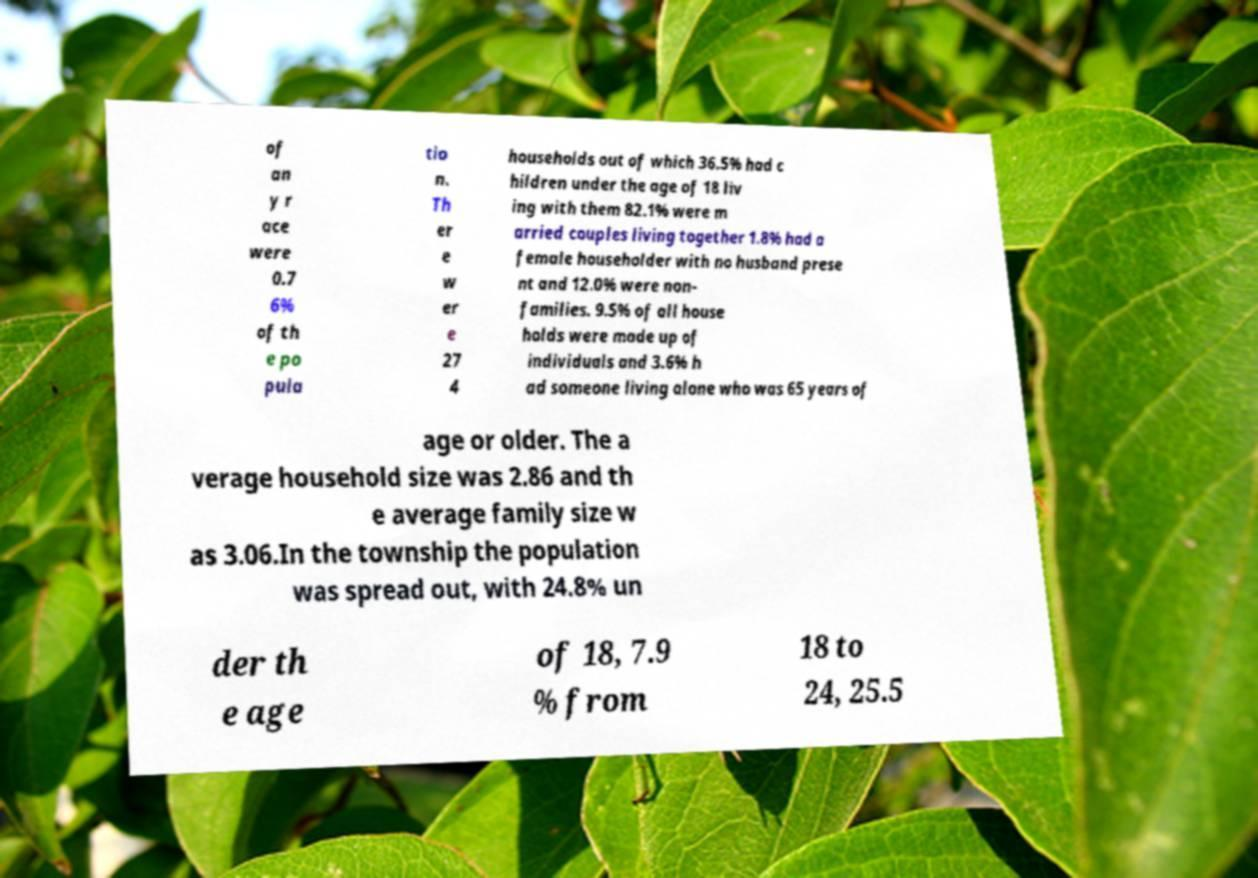Please read and relay the text visible in this image. What does it say? of an y r ace were 0.7 6% of th e po pula tio n. Th er e w er e 27 4 households out of which 36.5% had c hildren under the age of 18 liv ing with them 82.1% were m arried couples living together 1.8% had a female householder with no husband prese nt and 12.0% were non- families. 9.5% of all house holds were made up of individuals and 3.6% h ad someone living alone who was 65 years of age or older. The a verage household size was 2.86 and th e average family size w as 3.06.In the township the population was spread out, with 24.8% un der th e age of 18, 7.9 % from 18 to 24, 25.5 